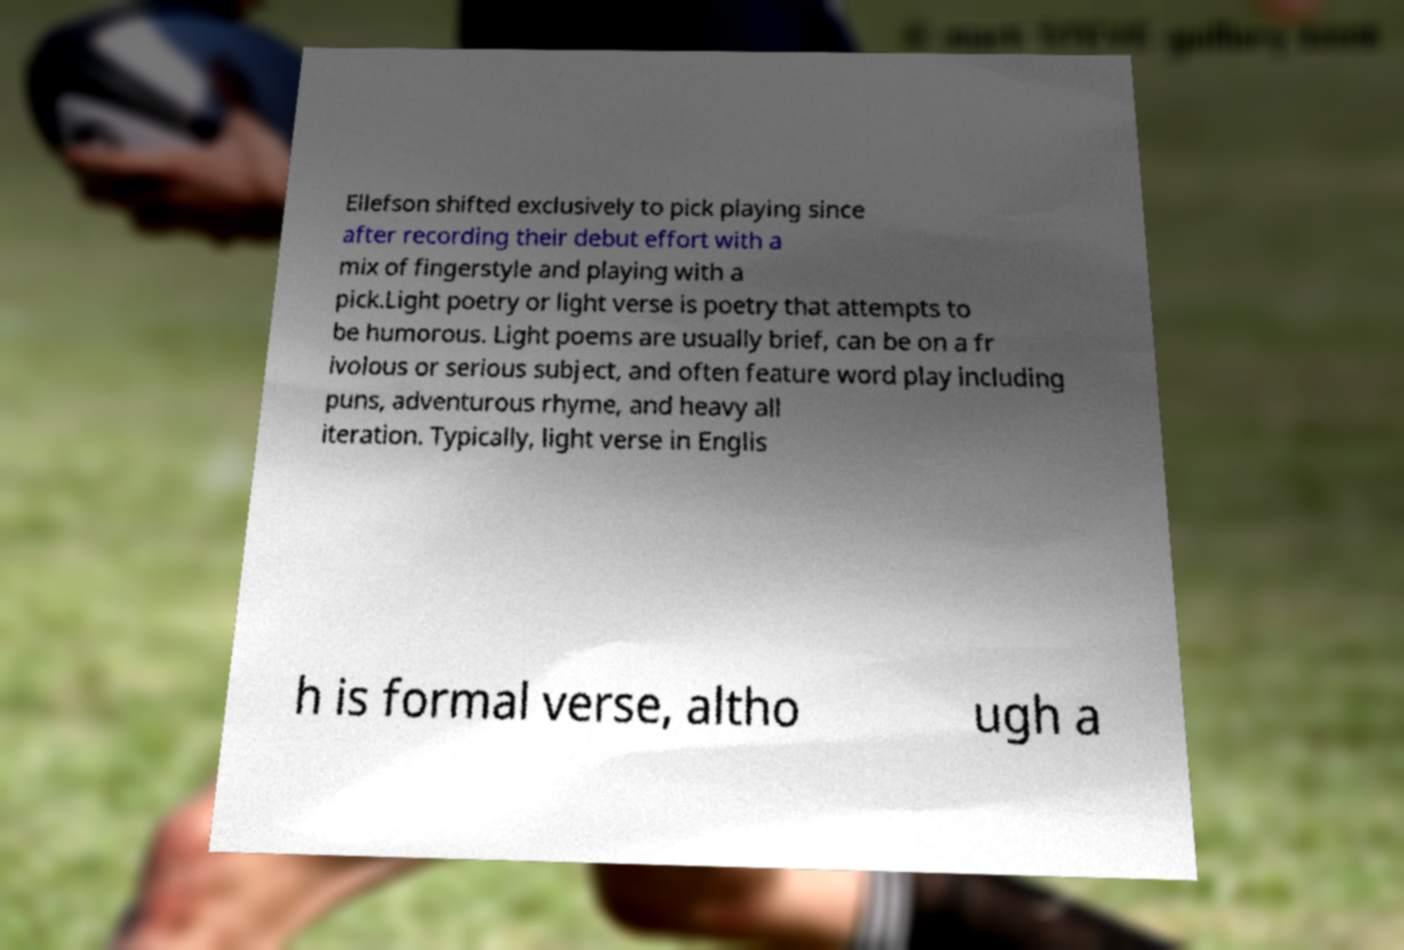Could you extract and type out the text from this image? Ellefson shifted exclusively to pick playing since after recording their debut effort with a mix of fingerstyle and playing with a pick.Light poetry or light verse is poetry that attempts to be humorous. Light poems are usually brief, can be on a fr ivolous or serious subject, and often feature word play including puns, adventurous rhyme, and heavy all iteration. Typically, light verse in Englis h is formal verse, altho ugh a 